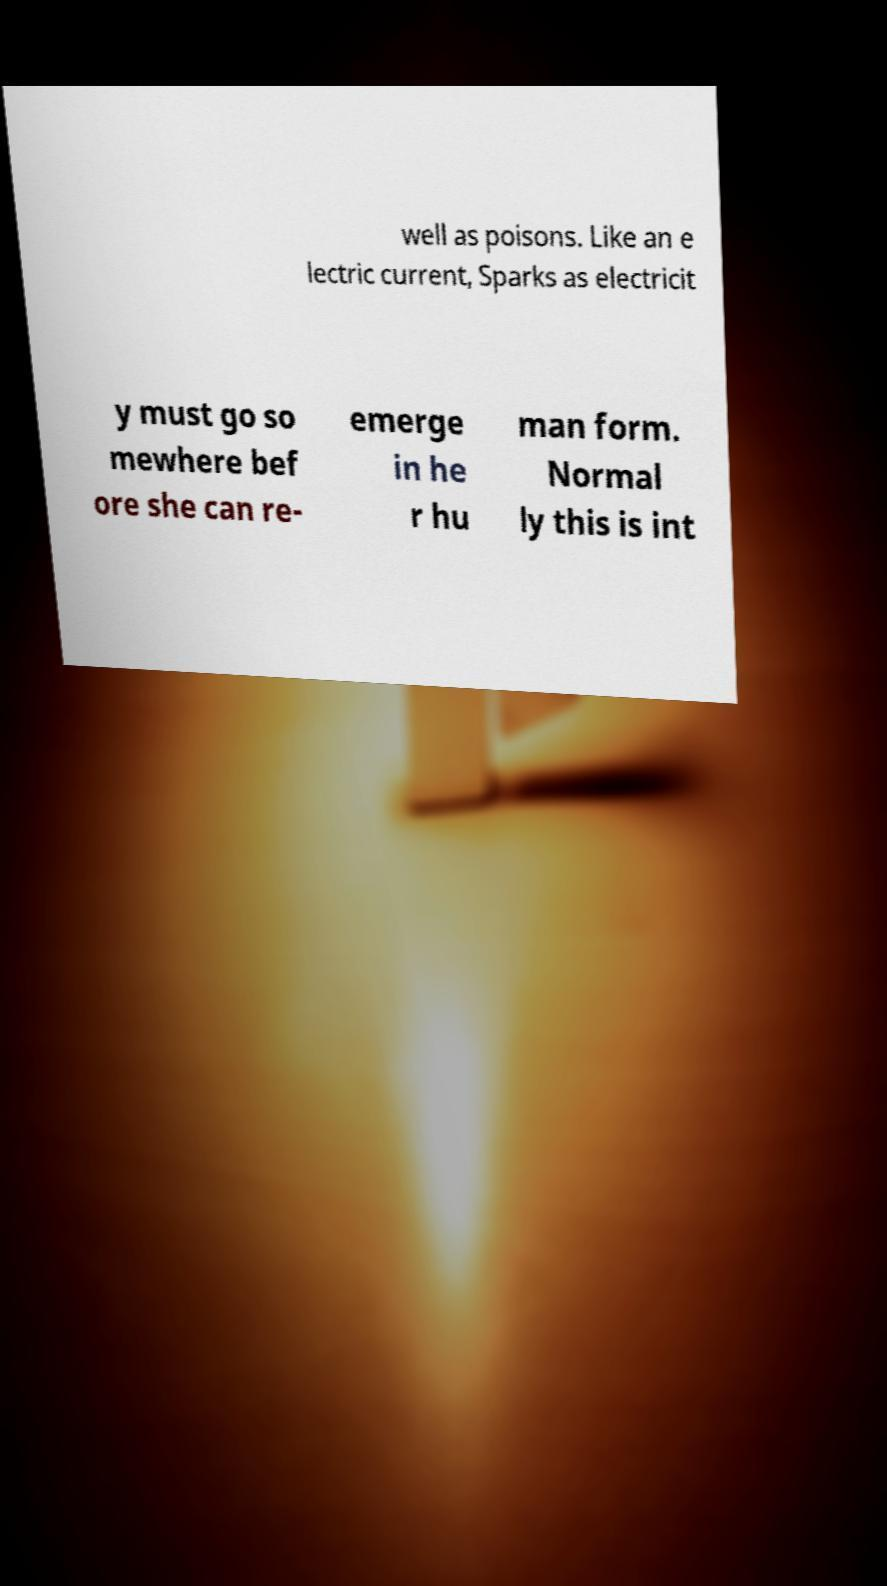Could you assist in decoding the text presented in this image and type it out clearly? well as poisons. Like an e lectric current, Sparks as electricit y must go so mewhere bef ore she can re- emerge in he r hu man form. Normal ly this is int 